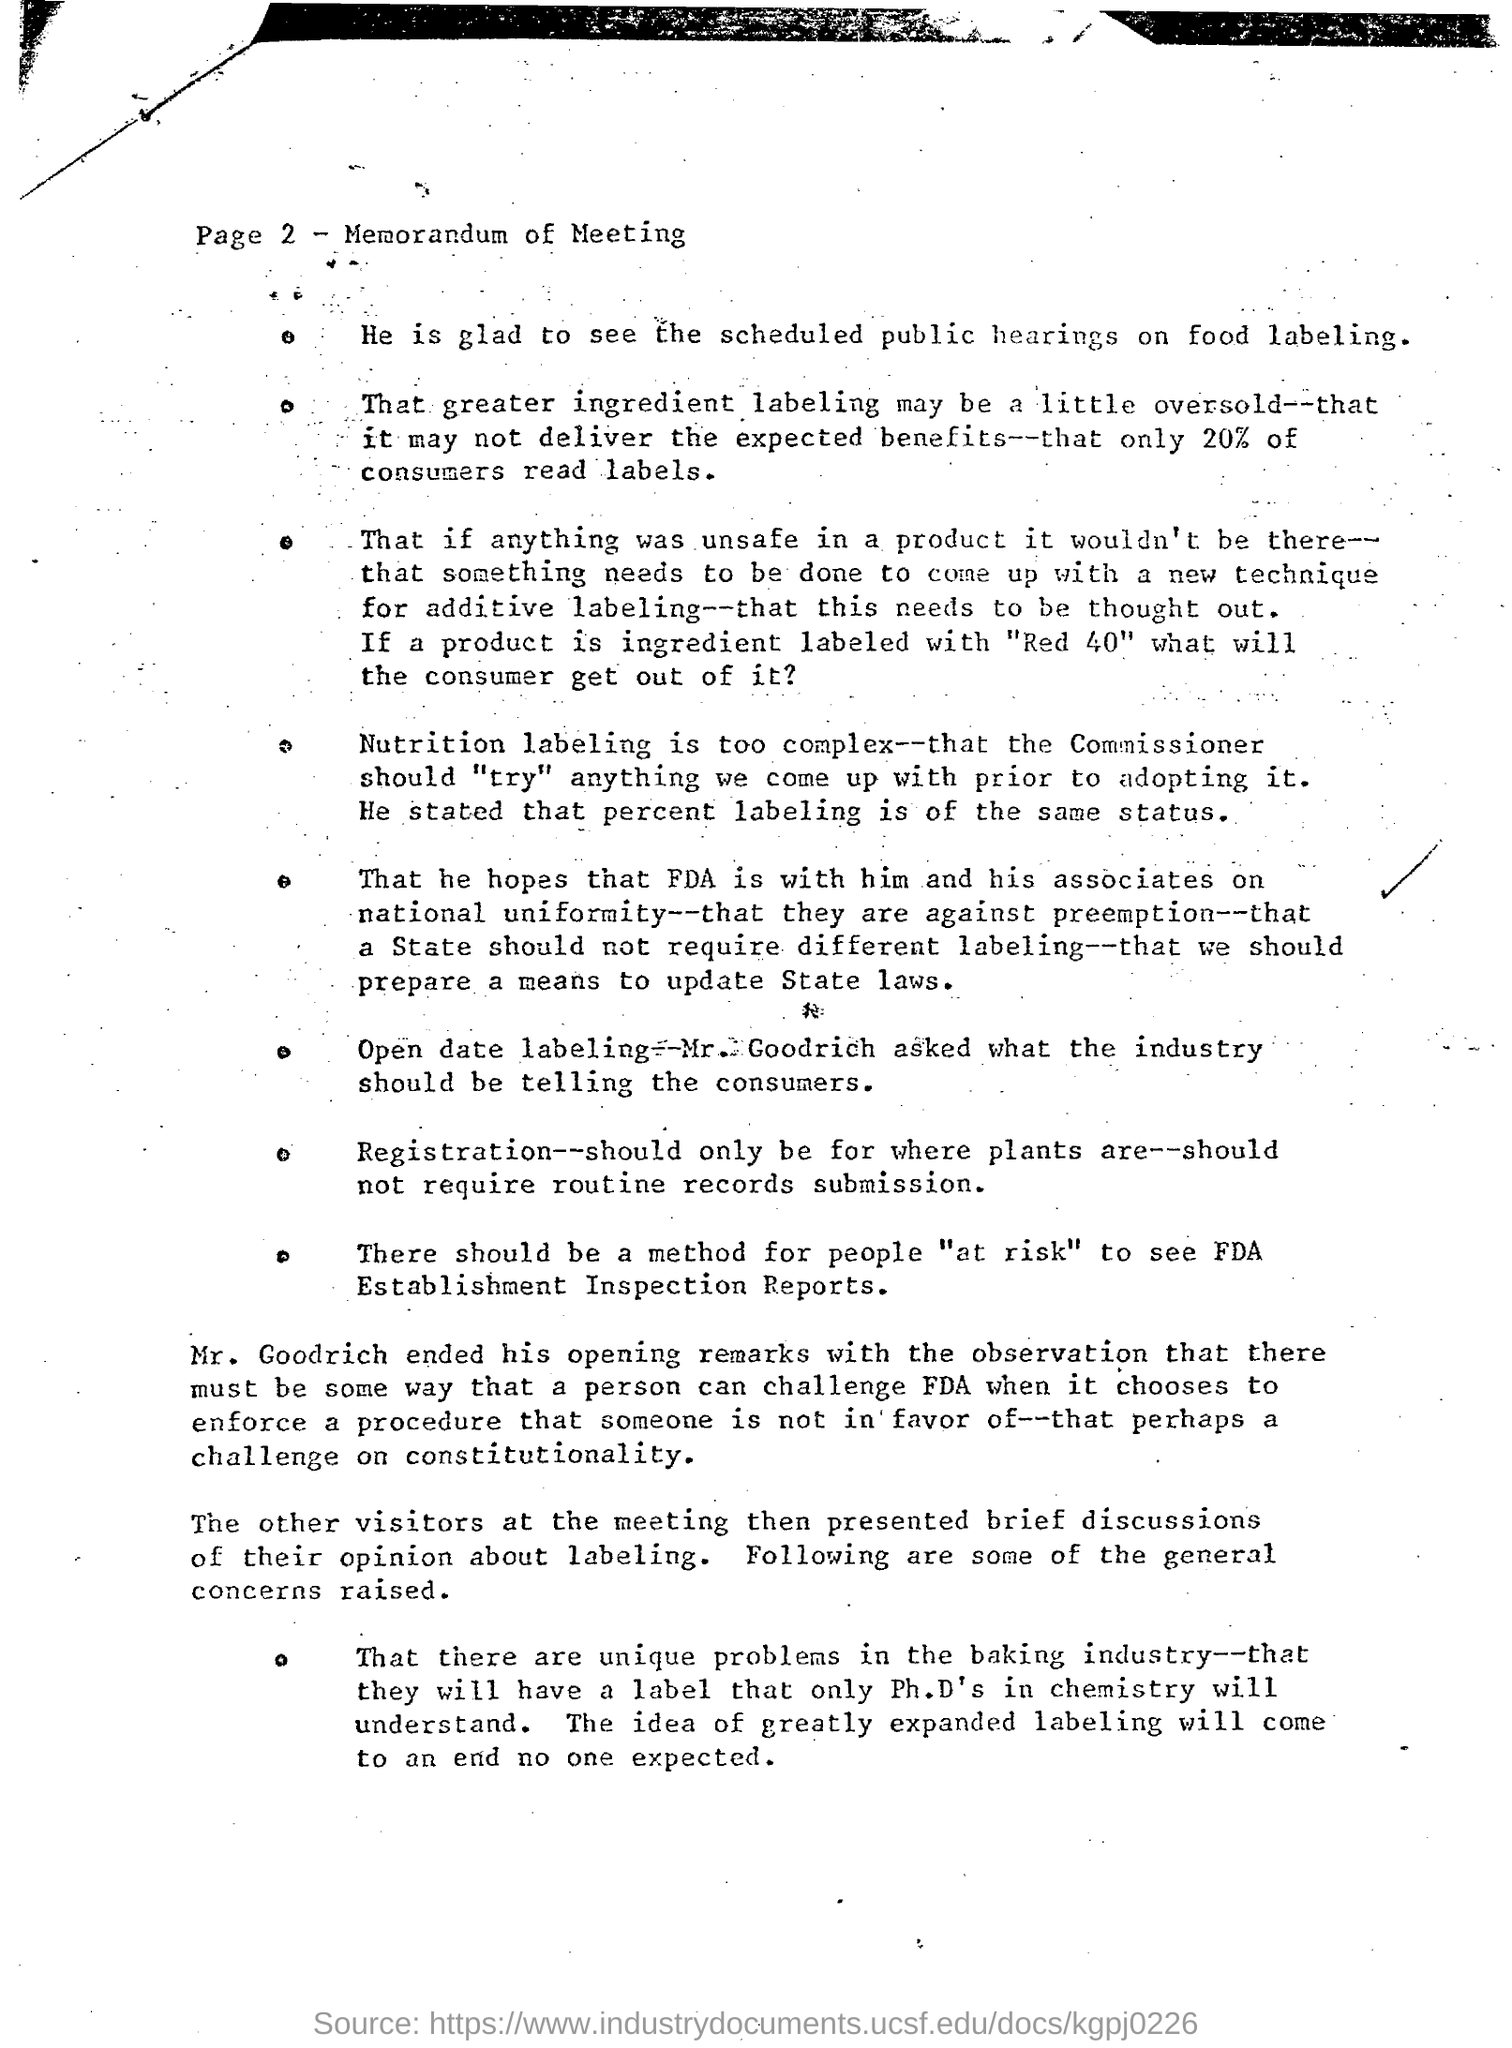Point out several critical features in this image. The heading of the document is "Memorandum of Meeting. According to a study, 20% of consumers read product labels before making a purchase. What are the scheduled public gatherings for food labeling? 